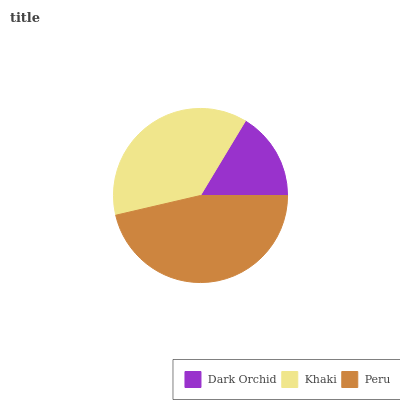Is Dark Orchid the minimum?
Answer yes or no. Yes. Is Peru the maximum?
Answer yes or no. Yes. Is Khaki the minimum?
Answer yes or no. No. Is Khaki the maximum?
Answer yes or no. No. Is Khaki greater than Dark Orchid?
Answer yes or no. Yes. Is Dark Orchid less than Khaki?
Answer yes or no. Yes. Is Dark Orchid greater than Khaki?
Answer yes or no. No. Is Khaki less than Dark Orchid?
Answer yes or no. No. Is Khaki the high median?
Answer yes or no. Yes. Is Khaki the low median?
Answer yes or no. Yes. Is Dark Orchid the high median?
Answer yes or no. No. Is Dark Orchid the low median?
Answer yes or no. No. 